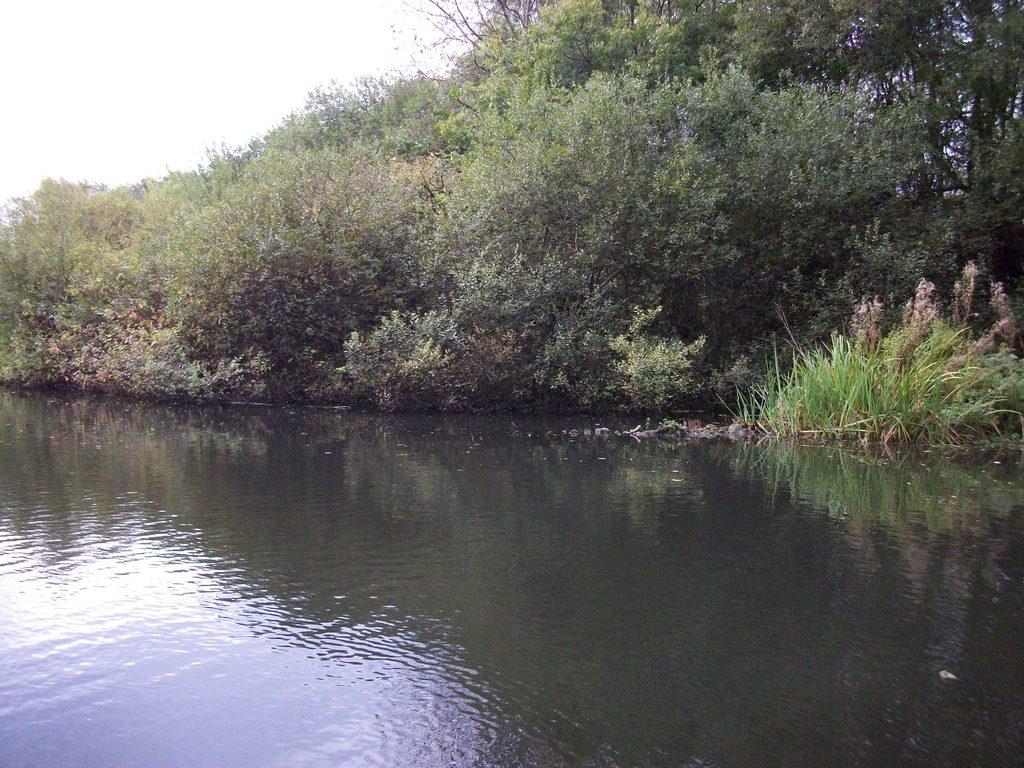What is visible at the bottom of the image? There is water visible at the bottom of the image. What can be seen in the background of the image? There are trees, plants, grass, and the sky visible in the background of the image. Where is the plate located in the image? There is no plate present in the image. What type of tank can be seen in the image? There is no tank present in the image. 